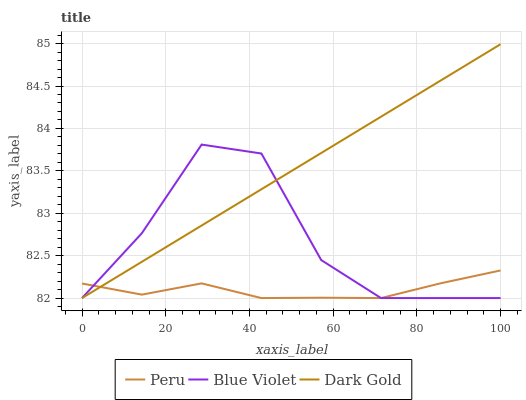Does Peru have the minimum area under the curve?
Answer yes or no. Yes. Does Dark Gold have the maximum area under the curve?
Answer yes or no. Yes. Does Dark Gold have the minimum area under the curve?
Answer yes or no. No. Does Peru have the maximum area under the curve?
Answer yes or no. No. Is Dark Gold the smoothest?
Answer yes or no. Yes. Is Blue Violet the roughest?
Answer yes or no. Yes. Is Peru the smoothest?
Answer yes or no. No. Is Peru the roughest?
Answer yes or no. No. Does Blue Violet have the lowest value?
Answer yes or no. Yes. Does Dark Gold have the highest value?
Answer yes or no. Yes. Does Peru have the highest value?
Answer yes or no. No. Does Peru intersect Dark Gold?
Answer yes or no. Yes. Is Peru less than Dark Gold?
Answer yes or no. No. Is Peru greater than Dark Gold?
Answer yes or no. No. 